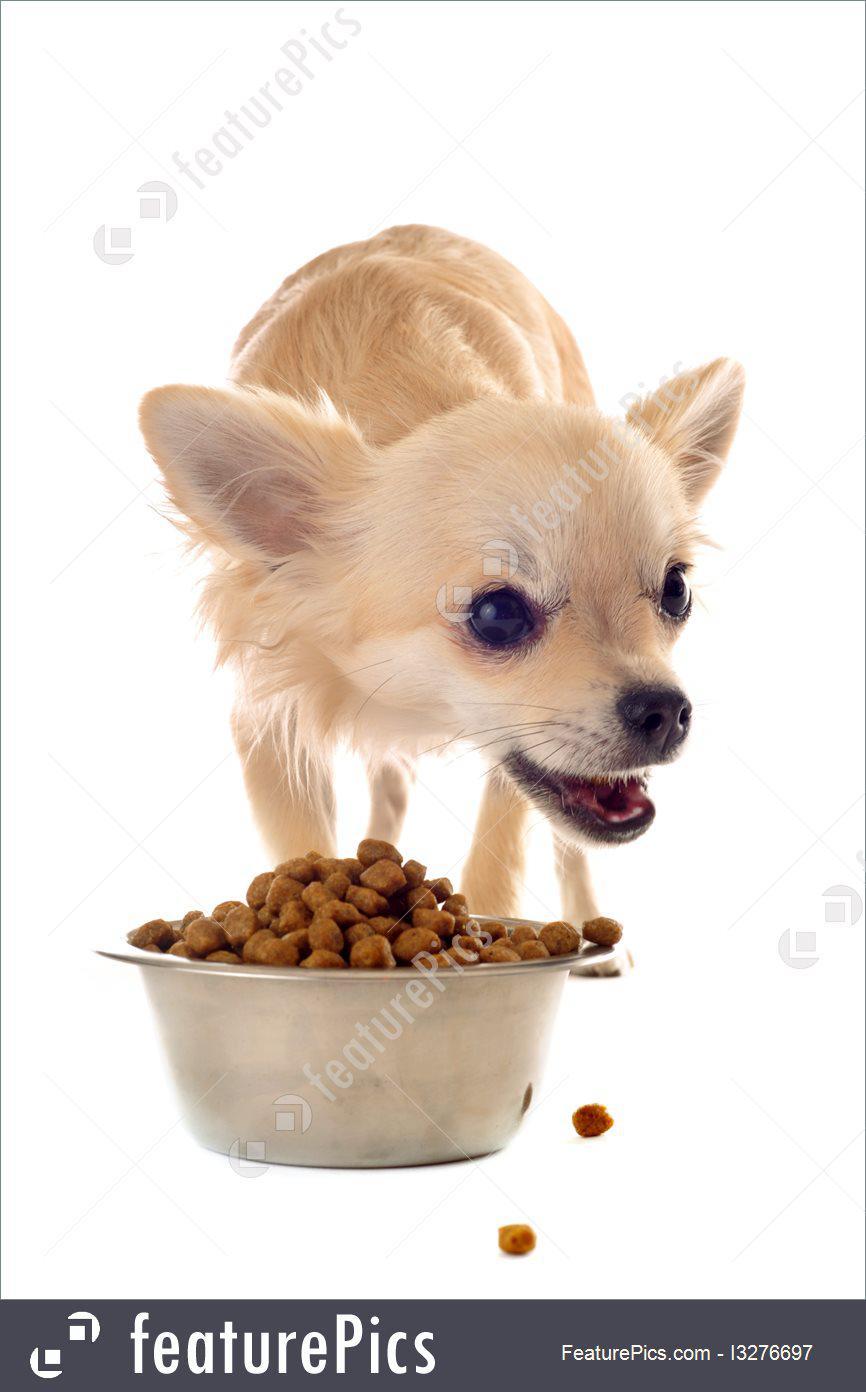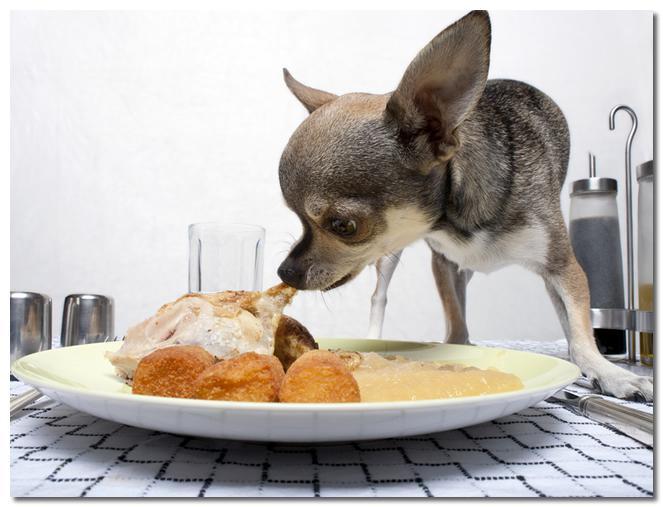The first image is the image on the left, the second image is the image on the right. Given the left and right images, does the statement "There is a dog standing beside a white plate full of food on a patterned table in one of the images." hold true? Answer yes or no. Yes. The first image is the image on the left, the second image is the image on the right. Given the left and right images, does the statement "One dog is eating strawberries." hold true? Answer yes or no. No. 